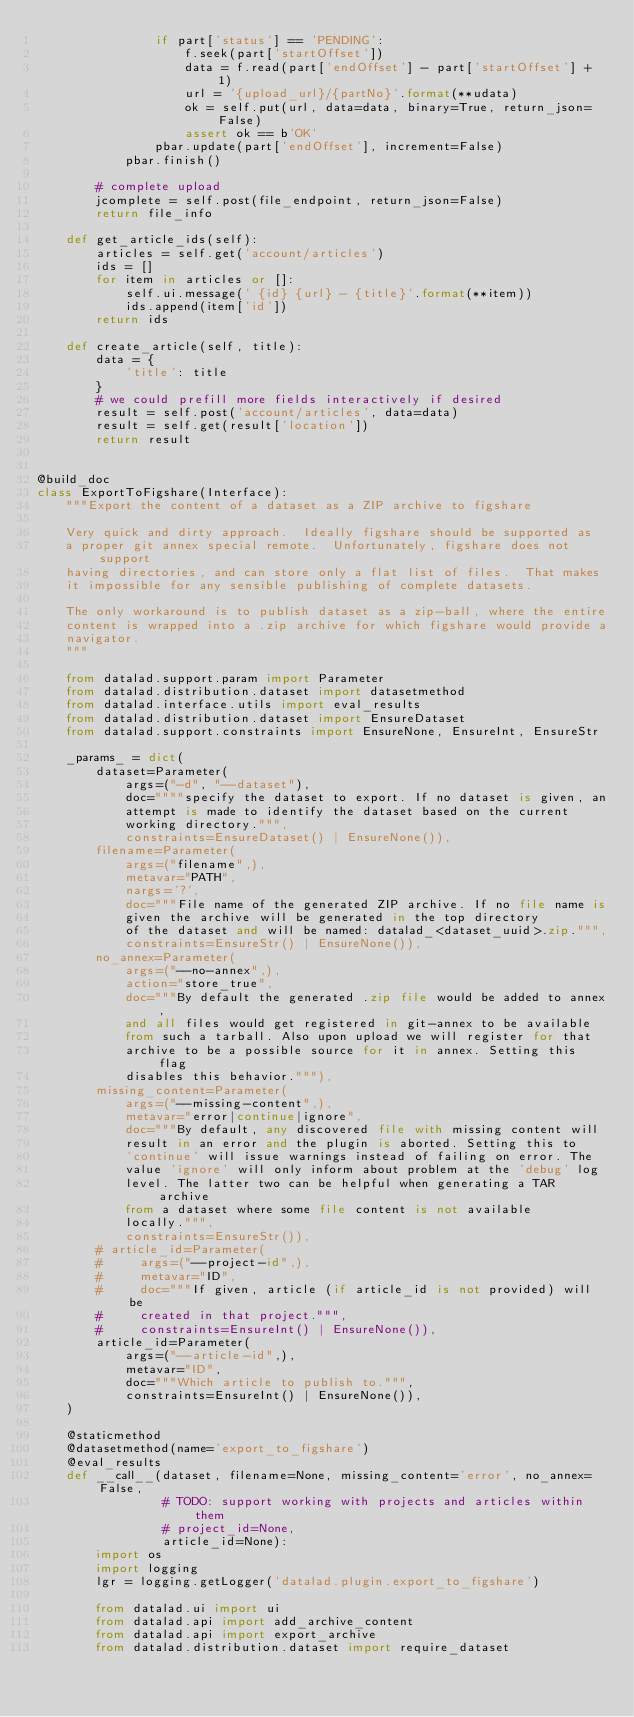<code> <loc_0><loc_0><loc_500><loc_500><_Python_>                if part['status'] == 'PENDING':
                    f.seek(part['startOffset'])
                    data = f.read(part['endOffset'] - part['startOffset'] + 1)
                    url = '{upload_url}/{partNo}'.format(**udata)
                    ok = self.put(url, data=data, binary=True, return_json=False)
                    assert ok == b'OK'
                pbar.update(part['endOffset'], increment=False)
            pbar.finish()

        # complete upload
        jcomplete = self.post(file_endpoint, return_json=False)
        return file_info

    def get_article_ids(self):
        articles = self.get('account/articles')
        ids = []
        for item in articles or []:
            self.ui.message(' {id} {url} - {title}'.format(**item))
            ids.append(item['id'])
        return ids

    def create_article(self, title):
        data = {
            'title': title
        }
        # we could prefill more fields interactively if desired
        result = self.post('account/articles', data=data)
        result = self.get(result['location'])
        return result


@build_doc
class ExportToFigshare(Interface):
    """Export the content of a dataset as a ZIP archive to figshare

    Very quick and dirty approach.  Ideally figshare should be supported as
    a proper git annex special remote.  Unfortunately, figshare does not support
    having directories, and can store only a flat list of files.  That makes
    it impossible for any sensible publishing of complete datasets.

    The only workaround is to publish dataset as a zip-ball, where the entire
    content is wrapped into a .zip archive for which figshare would provide a
    navigator.
    """

    from datalad.support.param import Parameter
    from datalad.distribution.dataset import datasetmethod
    from datalad.interface.utils import eval_results
    from datalad.distribution.dataset import EnsureDataset
    from datalad.support.constraints import EnsureNone, EnsureInt, EnsureStr

    _params_ = dict(
        dataset=Parameter(
            args=("-d", "--dataset"),
            doc=""""specify the dataset to export. If no dataset is given, an
            attempt is made to identify the dataset based on the current
            working directory.""",
            constraints=EnsureDataset() | EnsureNone()),
        filename=Parameter(
            args=("filename",),
            metavar="PATH",
            nargs='?',
            doc="""File name of the generated ZIP archive. If no file name is
            given the archive will be generated in the top directory
            of the dataset and will be named: datalad_<dataset_uuid>.zip.""",
            constraints=EnsureStr() | EnsureNone()),
        no_annex=Parameter(
            args=("--no-annex",),
            action="store_true",
            doc="""By default the generated .zip file would be added to annex,
            and all files would get registered in git-annex to be available
            from such a tarball. Also upon upload we will register for that
            archive to be a possible source for it in annex. Setting this flag
            disables this behavior."""),
        missing_content=Parameter(
            args=("--missing-content",),
            metavar="error|continue|ignore",
            doc="""By default, any discovered file with missing content will
            result in an error and the plugin is aborted. Setting this to
            'continue' will issue warnings instead of failing on error. The
            value 'ignore' will only inform about problem at the 'debug' log
            level. The latter two can be helpful when generating a TAR archive
            from a dataset where some file content is not available
            locally.""",
            constraints=EnsureStr()),
        # article_id=Parameter(
        #     args=("--project-id",),
        #     metavar="ID",
        #     doc="""If given, article (if article_id is not provided) will be
        #     created in that project.""",
        #     constraints=EnsureInt() | EnsureNone()),
        article_id=Parameter(
            args=("--article-id",),
            metavar="ID",
            doc="""Which article to publish to.""",
            constraints=EnsureInt() | EnsureNone()),
    )

    @staticmethod
    @datasetmethod(name='export_to_figshare')
    @eval_results
    def __call__(dataset, filename=None, missing_content='error', no_annex=False,
                 # TODO: support working with projects and articles within them
                 # project_id=None,
                 article_id=None):
        import os
        import logging
        lgr = logging.getLogger('datalad.plugin.export_to_figshare')

        from datalad.ui import ui
        from datalad.api import add_archive_content
        from datalad.api import export_archive
        from datalad.distribution.dataset import require_dataset</code> 